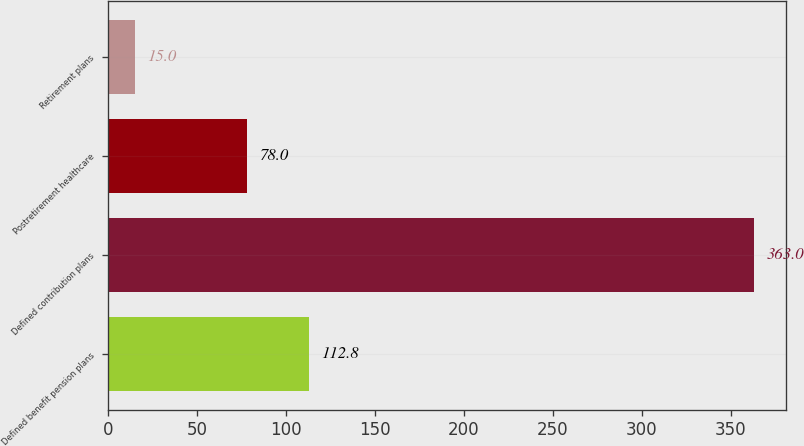Convert chart to OTSL. <chart><loc_0><loc_0><loc_500><loc_500><bar_chart><fcel>Defined benefit pension plans<fcel>Defined contribution plans<fcel>Postretirement healthcare<fcel>Retirement plans<nl><fcel>112.8<fcel>363<fcel>78<fcel>15<nl></chart> 